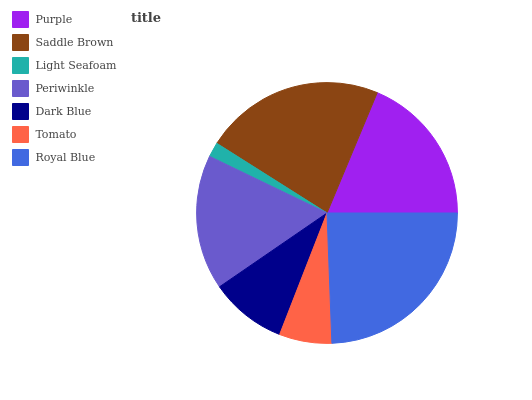Is Light Seafoam the minimum?
Answer yes or no. Yes. Is Royal Blue the maximum?
Answer yes or no. Yes. Is Saddle Brown the minimum?
Answer yes or no. No. Is Saddle Brown the maximum?
Answer yes or no. No. Is Saddle Brown greater than Purple?
Answer yes or no. Yes. Is Purple less than Saddle Brown?
Answer yes or no. Yes. Is Purple greater than Saddle Brown?
Answer yes or no. No. Is Saddle Brown less than Purple?
Answer yes or no. No. Is Periwinkle the high median?
Answer yes or no. Yes. Is Periwinkle the low median?
Answer yes or no. Yes. Is Purple the high median?
Answer yes or no. No. Is Purple the low median?
Answer yes or no. No. 